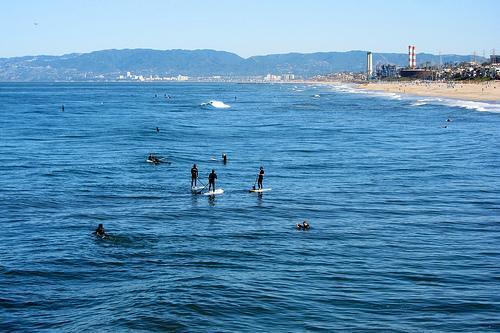How many are standing?
Give a very brief answer. 3. 